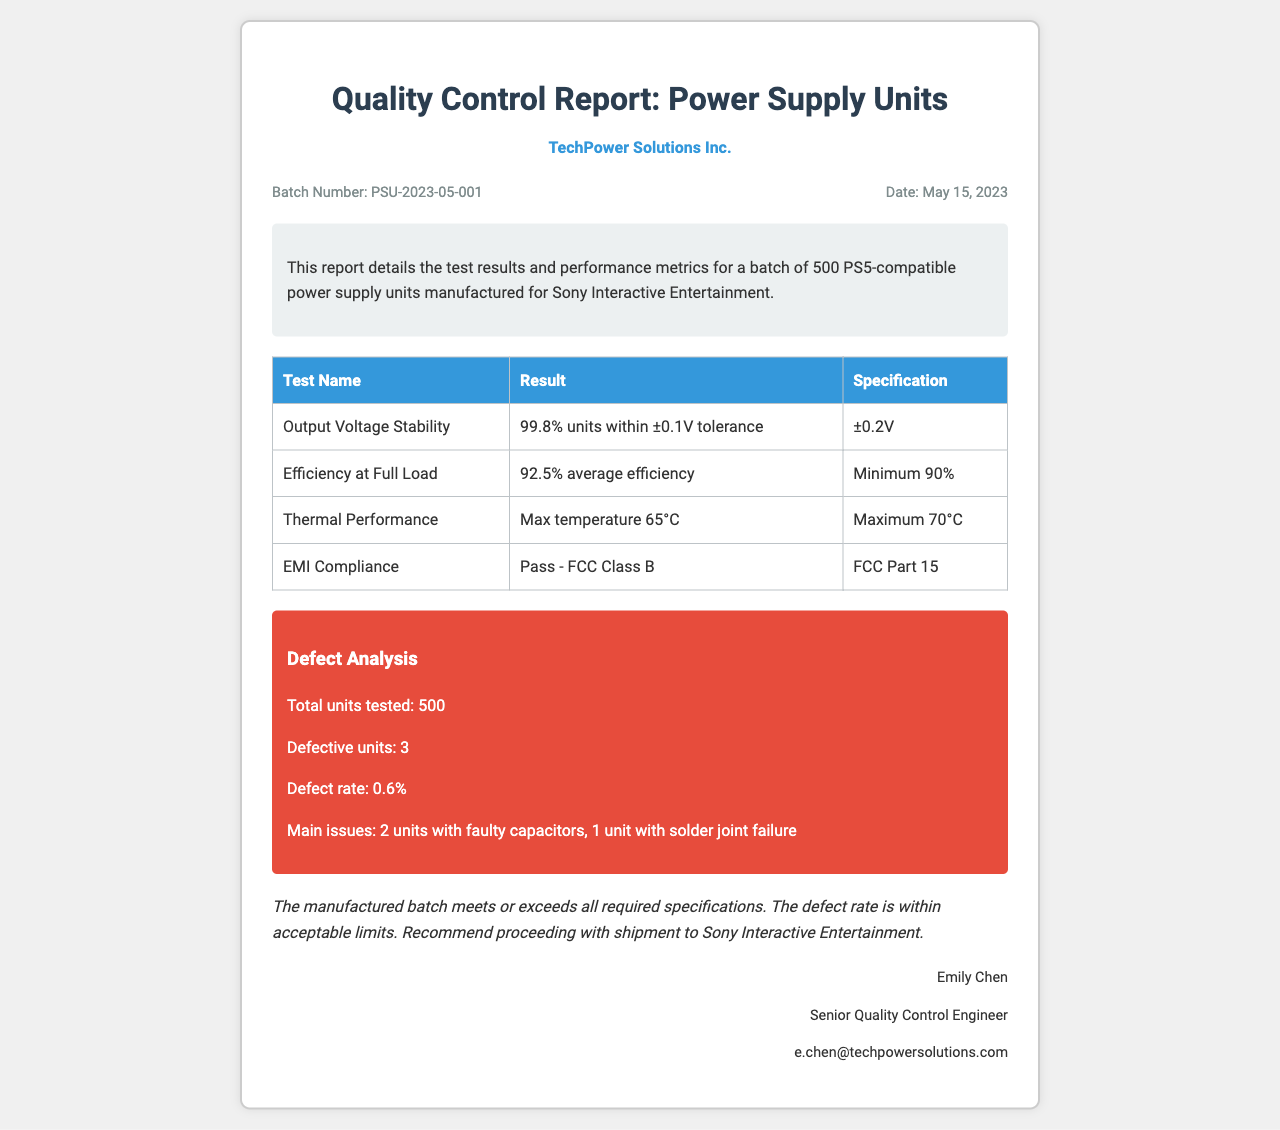What is the batch number? The batch number is a unique identifier mentioned in the document, specifically noted as PSU-2023-05-001.
Answer: PSU-2023-05-001 What is the total number of power supply units manufactured in this batch? The document states that a total of 500 PS5-compatible power supply units were manufactured for this batch.
Answer: 500 What is the maximum temperature recorded during thermal performance testing? The maximum temperature for thermal performance testing is noted in the document as 65°C, compared to the maximum specification.
Answer: 65°C What was the defect rate for the tested units? The defect rate is clearly indicated in the defect analysis section as 0.6%, providing insight into the quality of the batch.
Answer: 0.6% What were the main issues identified with the defective units? The document specifies the main issues found in the defective units, which include faulty capacitors and solder joint failure.
Answer: 2 units with faulty capacitors, 1 unit with solder joint failure What is the average efficiency at full load for the power supply units? The average efficiency at full load is stated as 92.5%, which is above the required minimum specification.
Answer: 92.5% Who is the senior quality control engineer listed in the report? The document includes the name of the senior quality control engineer, providing accountability and contact information regarding the report.
Answer: Emily Chen What compliance standard was passed during EMI testing? The EMI compliance section indicates the test passed under FCC Class B standards, ensuring electromagnetic interference regulations are met.
Answer: FCC Class B 